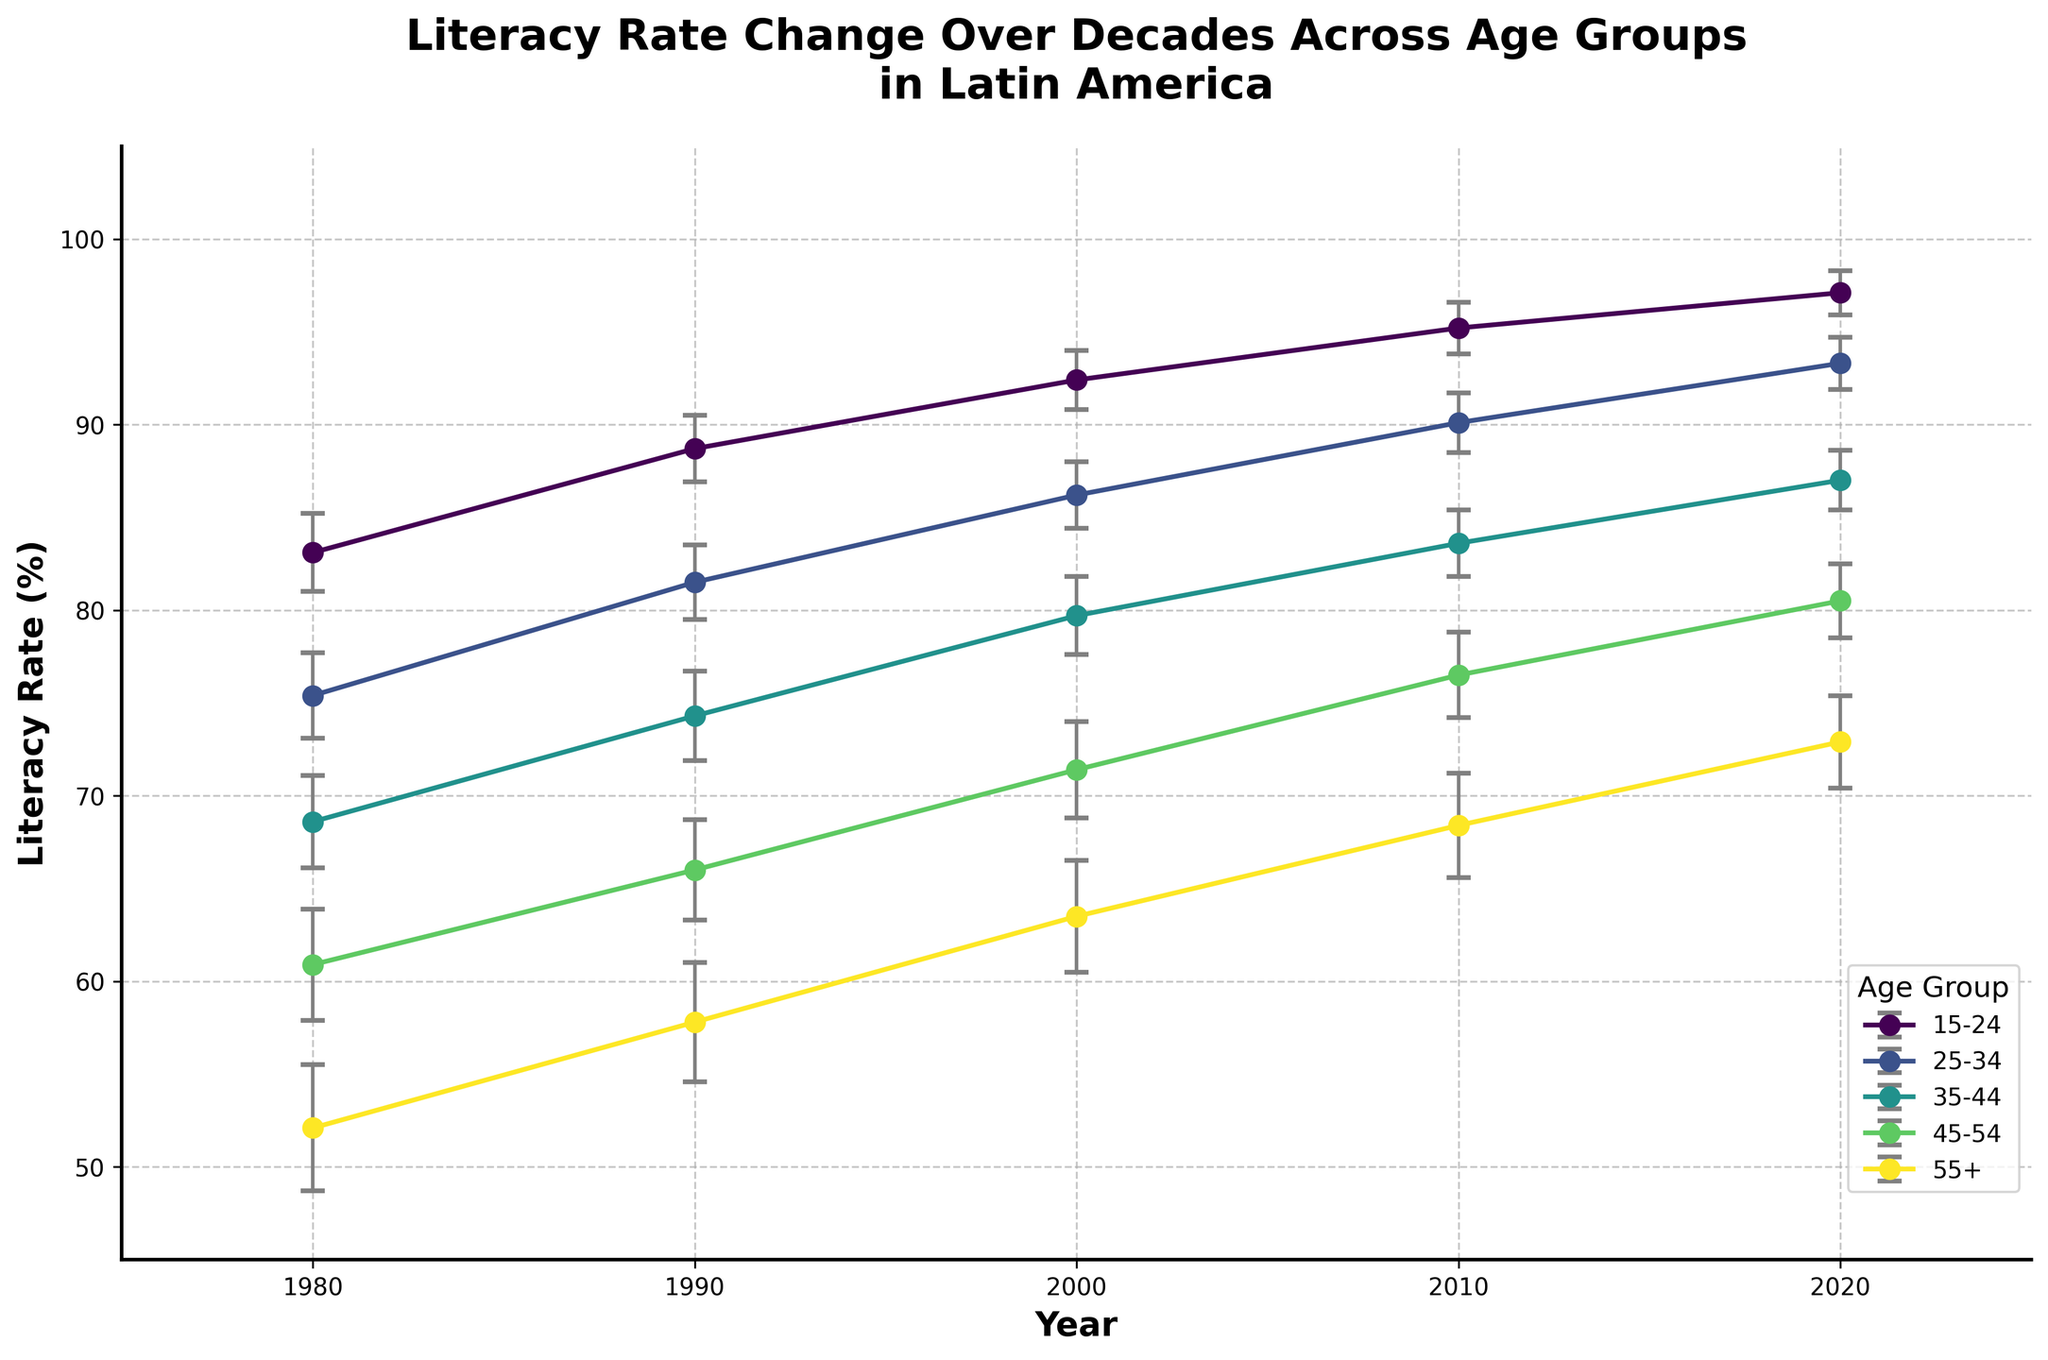What is the title of the figure? The title of the figure is usually found at the top and provides a summary of what the graph represents. The title here reads "Literacy Rate Change Over Decades Across Age Groups in Latin America."
Answer: Literacy Rate Change Over Decades Across Age Groups in Latin America What are the units for the y-axis? The y-axis represents the literacy rate, which is generally expressed in percentages (%). This can be inferred from the axis label "Literacy Rate (%)".
Answer: Percentage (%) Which age group had the highest literacy rate in 2020? By looking at the data points for the year 2020, you can observe that the age group 15-24 has the highest literacy rate.
Answer: 15-24 How does the literacy rate change for the 55+ age group from 1980 to 2020? To determine the change, look at the literacy rate for the 55+ group in 1980 (52.1%) and in 2020 (72.9%). The change is 72.9% - 52.1% = 20.8%.
Answer: It increased by 20.8% Which year showed the largest increase in literacy rate for the 25-34 age group compared to the previous decade? Examine the literacy rates for the 25-34 age group across the years. The change from 1980 to 1990 is 81.5% - 75.4% = 6.1%, from 1990 to 2000 is 86.2% - 81.5% = 4.7%, from 2000 to 2010 is 90.1% - 86.2% = 3.9%, and from 2010 to 2020 is 93.3% - 90.1% = 3.2%. The largest increase (6.1%) occurred between 1980 and 1990.
Answer: 1980-1990 Do any age groups have confidence intervals that overlap consistently across all decades? Confidence intervals are represented by the error bars. Observing the figure, you can see that age groups 35-44 and 45-54 have overlapping error bars consistently across all decades.
Answer: Yes What was the average literacy rate for the age group 45-54 over the entire period? To calculate the average, add all literacy rates for the 45-54 age group: (60.9 + 66.0 + 71.4 + 76.5 + 80.5) = 355.3. Then divide by the number of data points (5): 355.3 / 5 = 71.06.
Answer: 71.06% Which age group had the smallest standard deviation in 2000? Referring to the error bars or data table, the smallest standard deviation in 2000 is 1.6 for the age group 15-24.
Answer: 15-24 How did the literacy rate for the age group 35-44 change from 1980 to 2010? Compare the literacy rate for 35-44 in 1980 (68.6%) with that in 2010 (83.6%). The change is 83.6% - 68.6% = 15%.
Answer: Increased by 15% Which age group had the most significant improvement in literacy rate from 1980 to 2020? Calculate the difference in literacy rates from 1980 to 2020 for each age group. The improvements are: 
15-24: 97.1% - 83.1% = 14.0%
25-34: 93.3% - 75.4% = 17.9%
35-44: 87.0% - 68.6% = 18.4%
45-54: 80.5% - 60.9% = 19.6%
55+: 72.9% - 52.1% = 20.8%
The 55+ group shows the most significant improvement with a 20.8% increase.
Answer: 55+ 